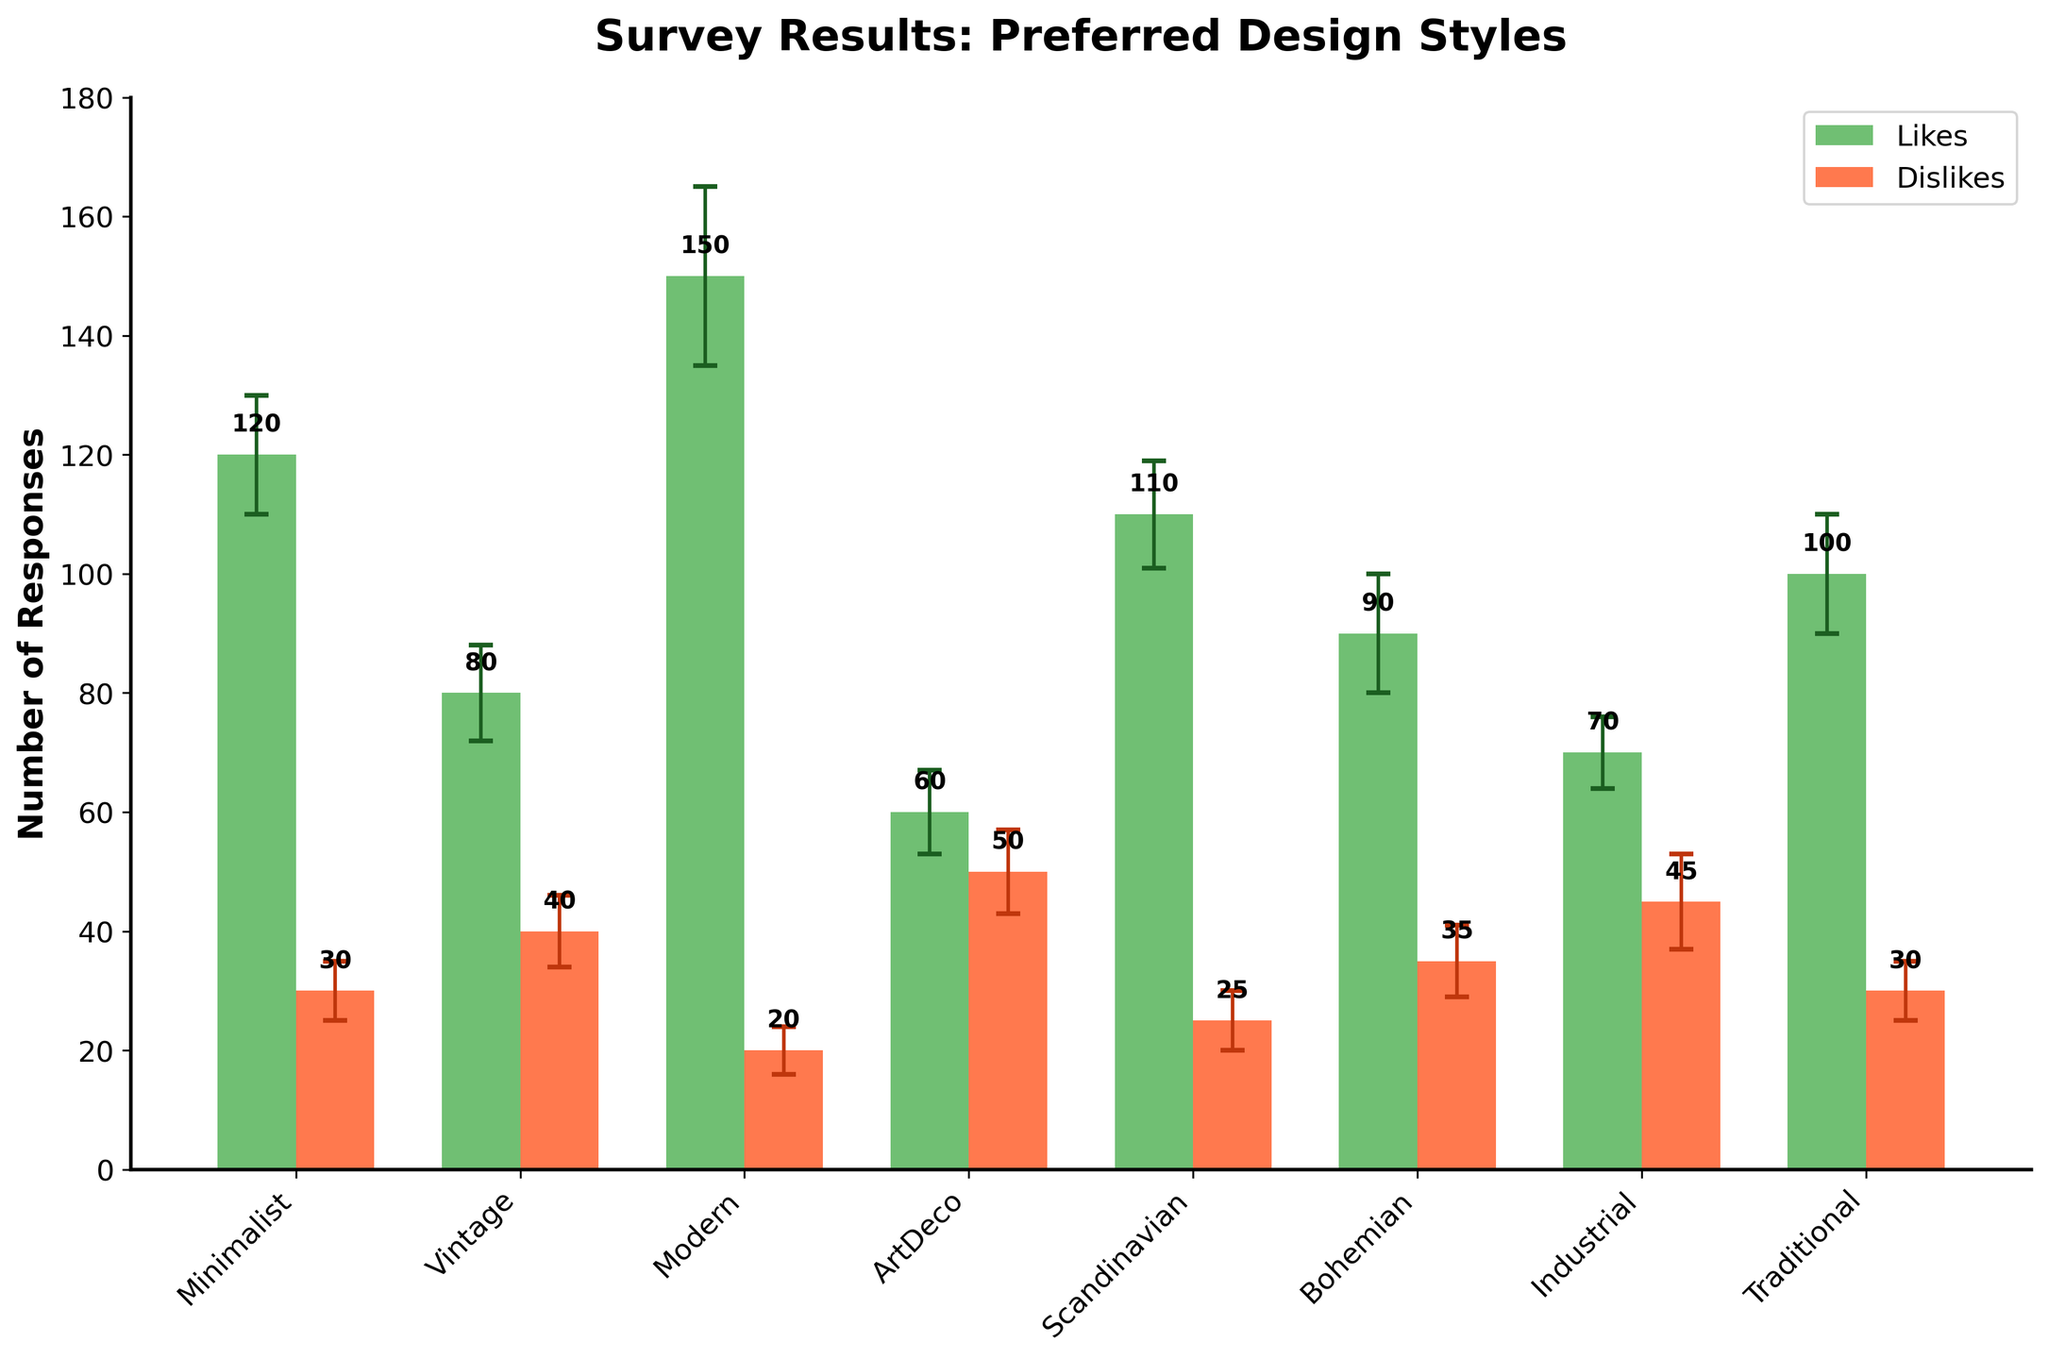Which design style received the highest number of likes? The bar representing the number of likes for each design style shows that the "Modern" style received 150 likes, which is the highest among all styles.
Answer: Modern How many design styles received more dislikes than likes? Comparing the heights of the bars for likes and dislikes for each design style, "ArtDeco" and "Industrial" received more dislikes than likes.
Answer: 2 What is the sum of likes for Minimalist and Scandinavian styles? The number of likes for Minimalist is 120 and for Scandinavian is 110. Adding them together gives 120 + 110 = 230.
Answer: 230 Which design style has the smallest difference between likes and dislikes? Calculating the absolute difference between the likes and dislikes for each style, "Traditional" shows the smallest difference (100 likes - 30 dislikes = 70).
Answer: Traditional What is the range of likes for the Bohemian design style including errors? The number of likes for Bohemian is 90, with an error of 10. Hence, the range is 90 ± 10, i.e., from 80 to 100.
Answer: 80 to 100 Which design style has the most precise measurement in dislikes? Comparing the error bars, the smallest error for dislikes is 4, which corresponds to the "Modern" style.
Answer: Modern By how much do the likes for Modern design style exceed those of Vintage? The number of likes for Modern is 150 and for Vintage is 80. The difference is 150 - 80 = 70.
Answer: 70 Which design style has the greatest variability in the number of likes? The greatest error for likes is 15, which corresponds to the "Modern" style.
Answer: Modern What is the average number of dislikes for ArtDeco and Industrial styles? The number of dislikes for ArtDeco is 50 and for Industrial is 45. The average is (50 + 45) / 2 = 47.5.
Answer: 47.5 